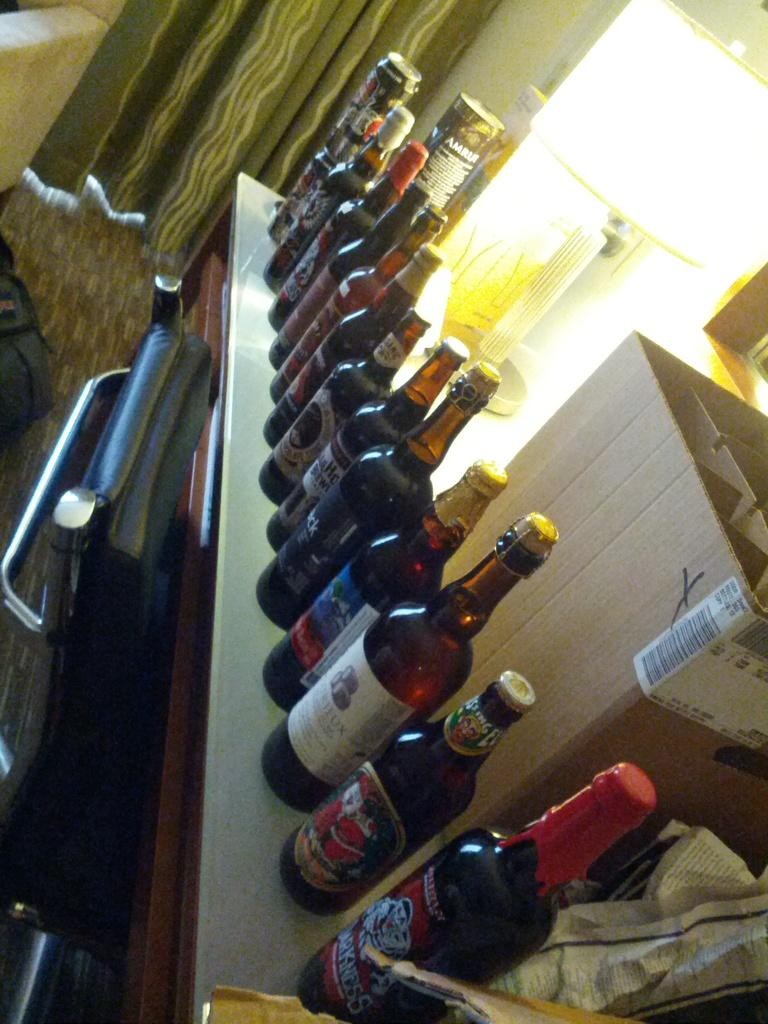What objects can be seen on the table in the image? There are many bottles on the table, as well as a cardboard box and a table lamp. What can be found in the background of the image? There are curtains and a bag in the background. What shape is the elbow of the person in the image? There is no person present in the image, so it is not possible to determine the shape of their elbow. 